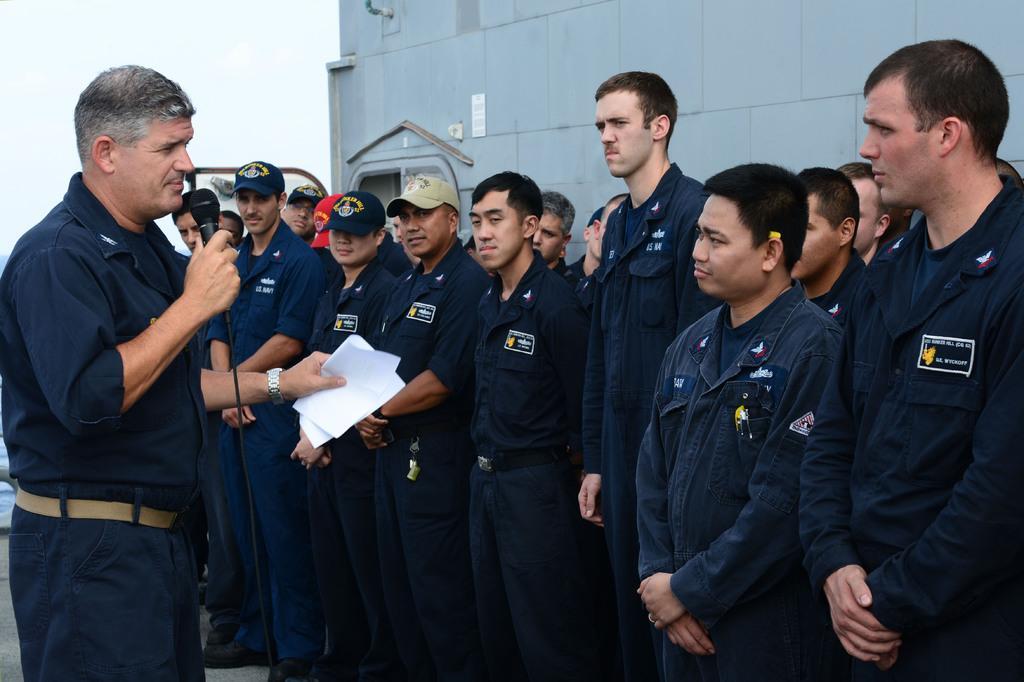In one or two sentences, can you explain what this image depicts? In this image we can see so many men are standing. They are wearing blue color uniforms. Behind them, there is a grey color wall. We the white color sky in the left top of the image. One man is standing on the left side of the image. He is wearing a dark blue color shirt with pant and holding the mic in one hand and a paper in the other hand. 